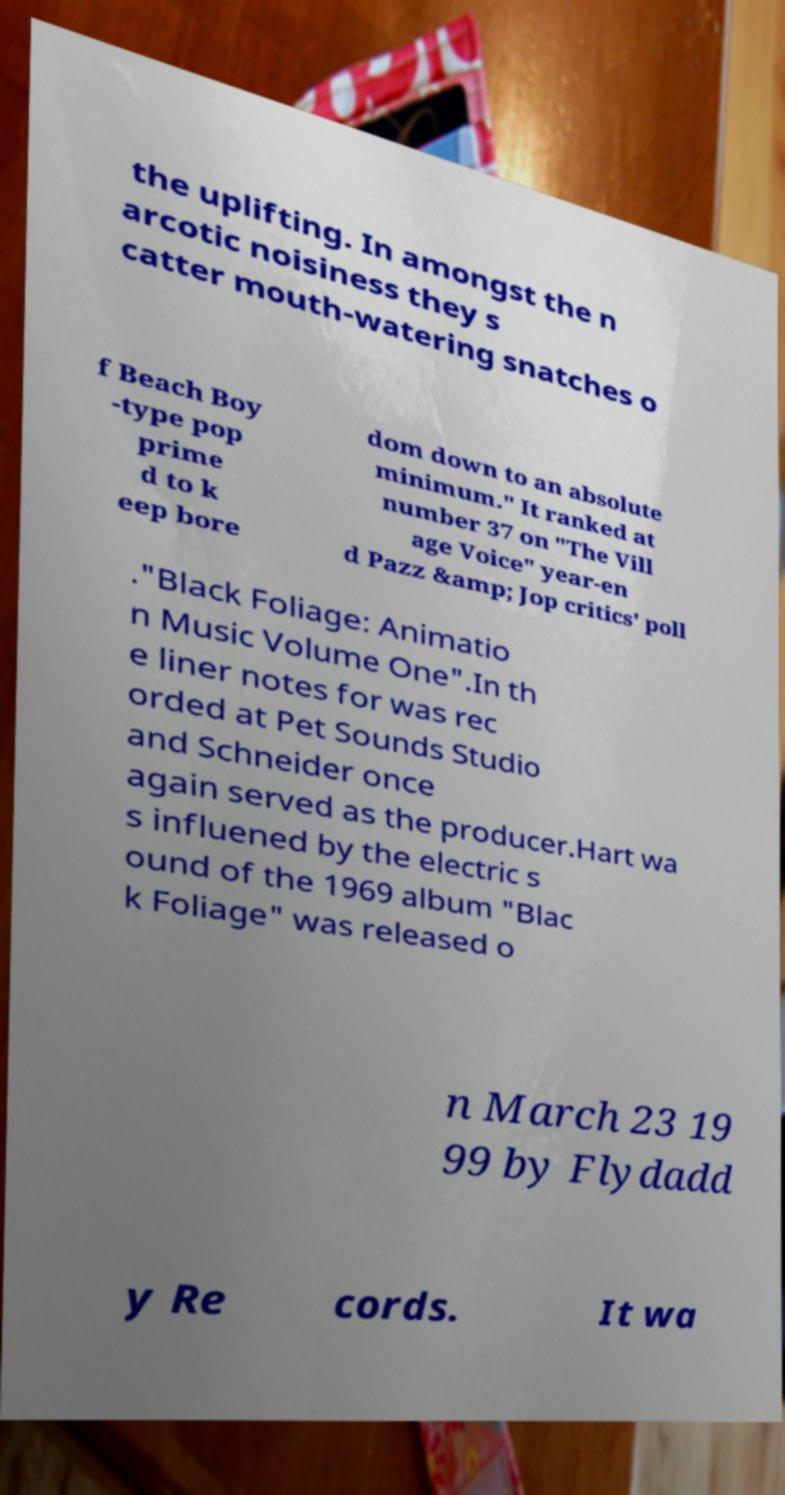Please identify and transcribe the text found in this image. the uplifting. In amongst the n arcotic noisiness they s catter mouth-watering snatches o f Beach Boy -type pop prime d to k eep bore dom down to an absolute minimum." It ranked at number 37 on "The Vill age Voice" year-en d Pazz &amp; Jop critics' poll ."Black Foliage: Animatio n Music Volume One".In th e liner notes for was rec orded at Pet Sounds Studio and Schneider once again served as the producer.Hart wa s influened by the electric s ound of the 1969 album "Blac k Foliage" was released o n March 23 19 99 by Flydadd y Re cords. It wa 